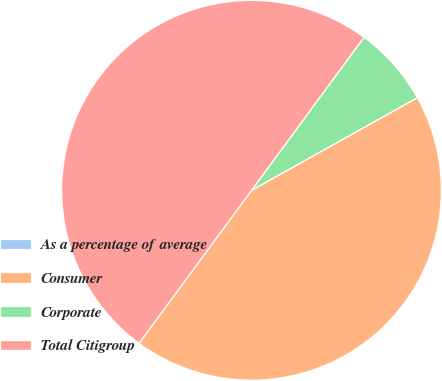Convert chart to OTSL. <chart><loc_0><loc_0><loc_500><loc_500><pie_chart><fcel>As a percentage of average<fcel>Consumer<fcel>Corporate<fcel>Total Citigroup<nl><fcel>0.0%<fcel>43.2%<fcel>6.8%<fcel>50.0%<nl></chart> 